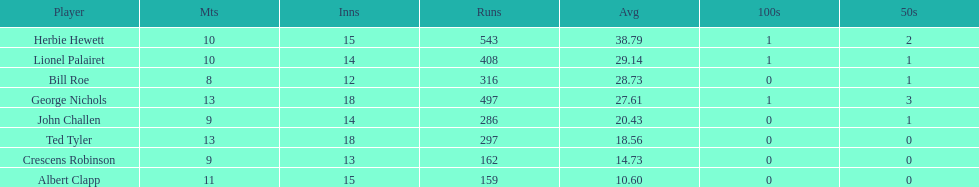Name a player whose average was above 25. Herbie Hewett. 